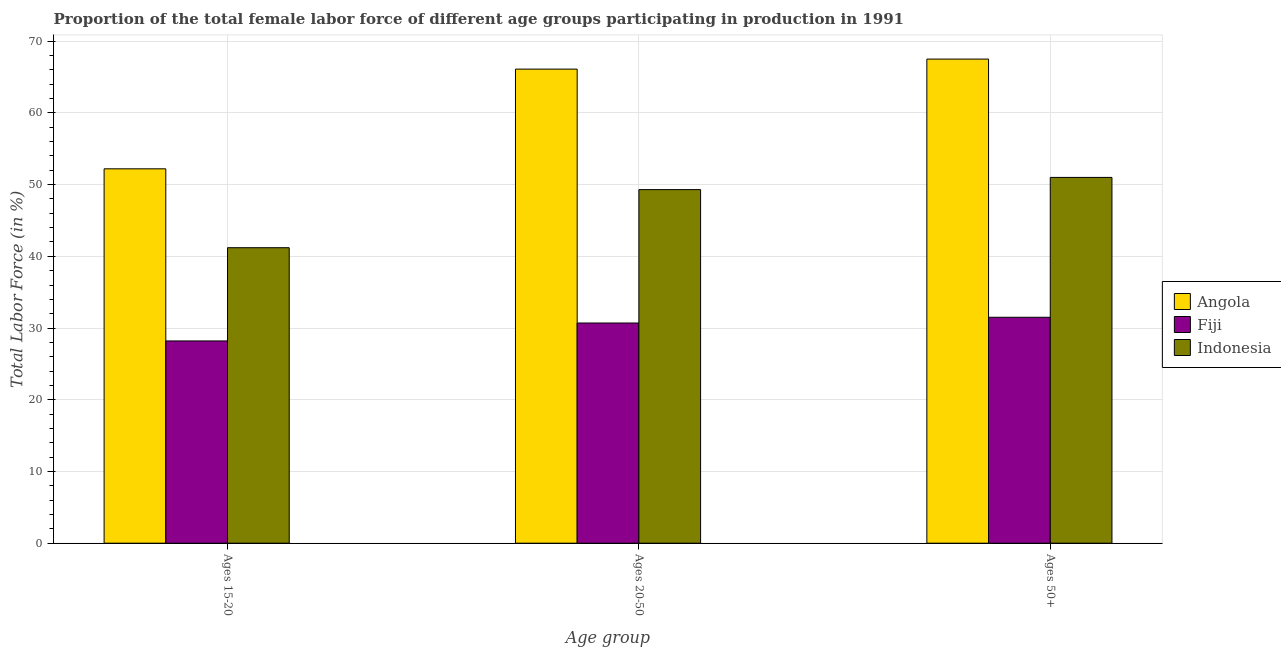How many different coloured bars are there?
Ensure brevity in your answer.  3. Are the number of bars per tick equal to the number of legend labels?
Your answer should be compact. Yes. What is the label of the 2nd group of bars from the left?
Provide a short and direct response. Ages 20-50. What is the percentage of female labor force within the age group 20-50 in Indonesia?
Give a very brief answer. 49.3. Across all countries, what is the maximum percentage of female labor force within the age group 20-50?
Provide a short and direct response. 66.1. Across all countries, what is the minimum percentage of female labor force within the age group 15-20?
Give a very brief answer. 28.2. In which country was the percentage of female labor force within the age group 20-50 maximum?
Make the answer very short. Angola. In which country was the percentage of female labor force within the age group 20-50 minimum?
Your answer should be compact. Fiji. What is the total percentage of female labor force within the age group 20-50 in the graph?
Your answer should be very brief. 146.1. What is the difference between the percentage of female labor force above age 50 in Fiji and that in Indonesia?
Offer a terse response. -19.5. What is the difference between the percentage of female labor force above age 50 in Fiji and the percentage of female labor force within the age group 15-20 in Angola?
Your response must be concise. -20.7. What is the average percentage of female labor force within the age group 15-20 per country?
Your answer should be compact. 40.53. What is the difference between the percentage of female labor force within the age group 15-20 and percentage of female labor force above age 50 in Indonesia?
Provide a succinct answer. -9.8. In how many countries, is the percentage of female labor force above age 50 greater than 46 %?
Keep it short and to the point. 2. What is the ratio of the percentage of female labor force above age 50 in Indonesia to that in Fiji?
Offer a very short reply. 1.62. What is the difference between the highest and the second highest percentage of female labor force within the age group 15-20?
Offer a very short reply. 11. What is the difference between the highest and the lowest percentage of female labor force within the age group 20-50?
Keep it short and to the point. 35.4. In how many countries, is the percentage of female labor force within the age group 20-50 greater than the average percentage of female labor force within the age group 20-50 taken over all countries?
Provide a short and direct response. 2. What does the 2nd bar from the left in Ages 20-50 represents?
Your answer should be compact. Fiji. What does the 2nd bar from the right in Ages 20-50 represents?
Offer a very short reply. Fiji. Are all the bars in the graph horizontal?
Your response must be concise. No. How many countries are there in the graph?
Provide a short and direct response. 3. What is the difference between two consecutive major ticks on the Y-axis?
Your answer should be very brief. 10. How many legend labels are there?
Your response must be concise. 3. What is the title of the graph?
Make the answer very short. Proportion of the total female labor force of different age groups participating in production in 1991. What is the label or title of the X-axis?
Make the answer very short. Age group. What is the Total Labor Force (in %) of Angola in Ages 15-20?
Provide a succinct answer. 52.2. What is the Total Labor Force (in %) in Fiji in Ages 15-20?
Make the answer very short. 28.2. What is the Total Labor Force (in %) of Indonesia in Ages 15-20?
Keep it short and to the point. 41.2. What is the Total Labor Force (in %) in Angola in Ages 20-50?
Your answer should be very brief. 66.1. What is the Total Labor Force (in %) in Fiji in Ages 20-50?
Keep it short and to the point. 30.7. What is the Total Labor Force (in %) of Indonesia in Ages 20-50?
Your answer should be very brief. 49.3. What is the Total Labor Force (in %) in Angola in Ages 50+?
Keep it short and to the point. 67.5. What is the Total Labor Force (in %) of Fiji in Ages 50+?
Provide a short and direct response. 31.5. What is the Total Labor Force (in %) of Indonesia in Ages 50+?
Your answer should be very brief. 51. Across all Age group, what is the maximum Total Labor Force (in %) of Angola?
Offer a terse response. 67.5. Across all Age group, what is the maximum Total Labor Force (in %) of Fiji?
Make the answer very short. 31.5. Across all Age group, what is the maximum Total Labor Force (in %) of Indonesia?
Ensure brevity in your answer.  51. Across all Age group, what is the minimum Total Labor Force (in %) of Angola?
Give a very brief answer. 52.2. Across all Age group, what is the minimum Total Labor Force (in %) of Fiji?
Your response must be concise. 28.2. Across all Age group, what is the minimum Total Labor Force (in %) in Indonesia?
Provide a short and direct response. 41.2. What is the total Total Labor Force (in %) of Angola in the graph?
Give a very brief answer. 185.8. What is the total Total Labor Force (in %) of Fiji in the graph?
Make the answer very short. 90.4. What is the total Total Labor Force (in %) in Indonesia in the graph?
Your answer should be very brief. 141.5. What is the difference between the Total Labor Force (in %) in Angola in Ages 15-20 and that in Ages 50+?
Offer a terse response. -15.3. What is the difference between the Total Labor Force (in %) of Fiji in Ages 15-20 and that in Ages 50+?
Provide a succinct answer. -3.3. What is the difference between the Total Labor Force (in %) in Indonesia in Ages 15-20 and that in Ages 50+?
Offer a terse response. -9.8. What is the difference between the Total Labor Force (in %) of Angola in Ages 20-50 and that in Ages 50+?
Your answer should be very brief. -1.4. What is the difference between the Total Labor Force (in %) of Indonesia in Ages 20-50 and that in Ages 50+?
Provide a succinct answer. -1.7. What is the difference between the Total Labor Force (in %) in Fiji in Ages 15-20 and the Total Labor Force (in %) in Indonesia in Ages 20-50?
Provide a succinct answer. -21.1. What is the difference between the Total Labor Force (in %) of Angola in Ages 15-20 and the Total Labor Force (in %) of Fiji in Ages 50+?
Provide a short and direct response. 20.7. What is the difference between the Total Labor Force (in %) of Angola in Ages 15-20 and the Total Labor Force (in %) of Indonesia in Ages 50+?
Provide a short and direct response. 1.2. What is the difference between the Total Labor Force (in %) in Fiji in Ages 15-20 and the Total Labor Force (in %) in Indonesia in Ages 50+?
Your answer should be very brief. -22.8. What is the difference between the Total Labor Force (in %) in Angola in Ages 20-50 and the Total Labor Force (in %) in Fiji in Ages 50+?
Offer a very short reply. 34.6. What is the difference between the Total Labor Force (in %) in Angola in Ages 20-50 and the Total Labor Force (in %) in Indonesia in Ages 50+?
Offer a very short reply. 15.1. What is the difference between the Total Labor Force (in %) in Fiji in Ages 20-50 and the Total Labor Force (in %) in Indonesia in Ages 50+?
Your response must be concise. -20.3. What is the average Total Labor Force (in %) of Angola per Age group?
Ensure brevity in your answer.  61.93. What is the average Total Labor Force (in %) in Fiji per Age group?
Make the answer very short. 30.13. What is the average Total Labor Force (in %) in Indonesia per Age group?
Your response must be concise. 47.17. What is the difference between the Total Labor Force (in %) of Angola and Total Labor Force (in %) of Fiji in Ages 15-20?
Ensure brevity in your answer.  24. What is the difference between the Total Labor Force (in %) in Fiji and Total Labor Force (in %) in Indonesia in Ages 15-20?
Your response must be concise. -13. What is the difference between the Total Labor Force (in %) in Angola and Total Labor Force (in %) in Fiji in Ages 20-50?
Provide a short and direct response. 35.4. What is the difference between the Total Labor Force (in %) in Angola and Total Labor Force (in %) in Indonesia in Ages 20-50?
Your answer should be very brief. 16.8. What is the difference between the Total Labor Force (in %) of Fiji and Total Labor Force (in %) of Indonesia in Ages 20-50?
Give a very brief answer. -18.6. What is the difference between the Total Labor Force (in %) in Angola and Total Labor Force (in %) in Indonesia in Ages 50+?
Your response must be concise. 16.5. What is the difference between the Total Labor Force (in %) in Fiji and Total Labor Force (in %) in Indonesia in Ages 50+?
Give a very brief answer. -19.5. What is the ratio of the Total Labor Force (in %) in Angola in Ages 15-20 to that in Ages 20-50?
Your answer should be very brief. 0.79. What is the ratio of the Total Labor Force (in %) in Fiji in Ages 15-20 to that in Ages 20-50?
Your answer should be very brief. 0.92. What is the ratio of the Total Labor Force (in %) of Indonesia in Ages 15-20 to that in Ages 20-50?
Provide a short and direct response. 0.84. What is the ratio of the Total Labor Force (in %) in Angola in Ages 15-20 to that in Ages 50+?
Your answer should be very brief. 0.77. What is the ratio of the Total Labor Force (in %) in Fiji in Ages 15-20 to that in Ages 50+?
Your answer should be very brief. 0.9. What is the ratio of the Total Labor Force (in %) in Indonesia in Ages 15-20 to that in Ages 50+?
Your answer should be very brief. 0.81. What is the ratio of the Total Labor Force (in %) of Angola in Ages 20-50 to that in Ages 50+?
Offer a terse response. 0.98. What is the ratio of the Total Labor Force (in %) of Fiji in Ages 20-50 to that in Ages 50+?
Offer a terse response. 0.97. What is the ratio of the Total Labor Force (in %) in Indonesia in Ages 20-50 to that in Ages 50+?
Your answer should be compact. 0.97. What is the difference between the highest and the second highest Total Labor Force (in %) in Angola?
Give a very brief answer. 1.4. What is the difference between the highest and the second highest Total Labor Force (in %) in Fiji?
Your answer should be compact. 0.8. What is the difference between the highest and the lowest Total Labor Force (in %) in Angola?
Provide a short and direct response. 15.3. What is the difference between the highest and the lowest Total Labor Force (in %) of Fiji?
Give a very brief answer. 3.3. 